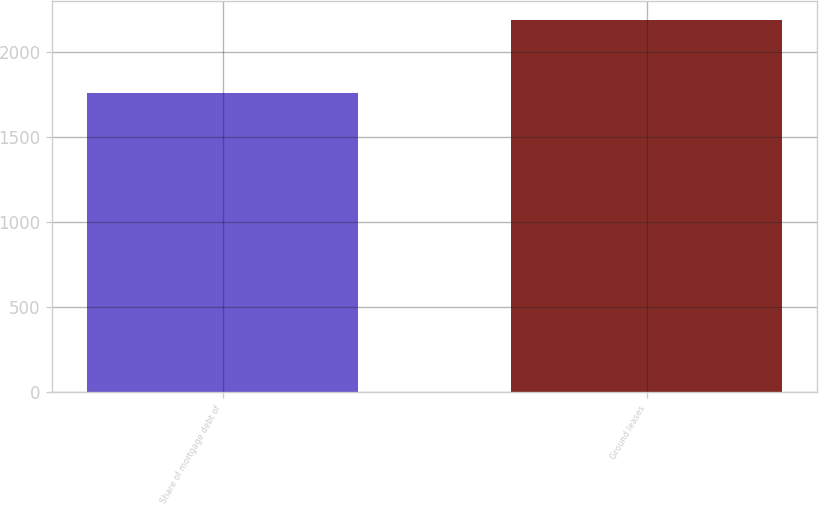Convert chart. <chart><loc_0><loc_0><loc_500><loc_500><bar_chart><fcel>Share of mortgage debt of<fcel>Ground leases<nl><fcel>1757<fcel>2185<nl></chart> 